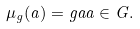Convert formula to latex. <formula><loc_0><loc_0><loc_500><loc_500>\mu _ { g } ( a ) = g a a \in G .</formula> 